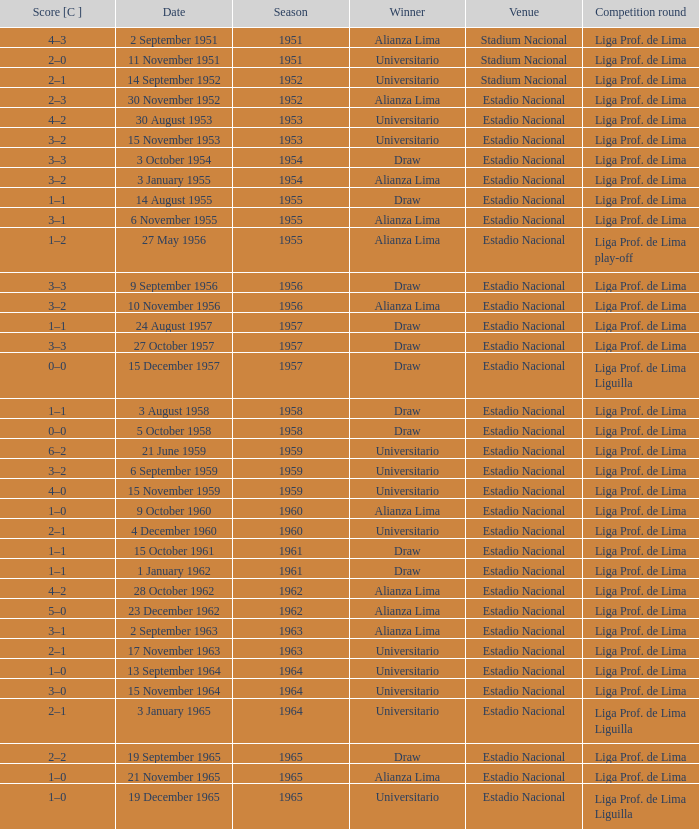What venue had an event on 17 November 1963? Estadio Nacional. Could you parse the entire table? {'header': ['Score [C ]', 'Date', 'Season', 'Winner', 'Venue', 'Competition round'], 'rows': [['4–3', '2 September 1951', '1951', 'Alianza Lima', 'Stadium Nacional', 'Liga Prof. de Lima'], ['2–0', '11 November 1951', '1951', 'Universitario', 'Stadium Nacional', 'Liga Prof. de Lima'], ['2–1', '14 September 1952', '1952', 'Universitario', 'Stadium Nacional', 'Liga Prof. de Lima'], ['2–3', '30 November 1952', '1952', 'Alianza Lima', 'Estadio Nacional', 'Liga Prof. de Lima'], ['4–2', '30 August 1953', '1953', 'Universitario', 'Estadio Nacional', 'Liga Prof. de Lima'], ['3–2', '15 November 1953', '1953', 'Universitario', 'Estadio Nacional', 'Liga Prof. de Lima'], ['3–3', '3 October 1954', '1954', 'Draw', 'Estadio Nacional', 'Liga Prof. de Lima'], ['3–2', '3 January 1955', '1954', 'Alianza Lima', 'Estadio Nacional', 'Liga Prof. de Lima'], ['1–1', '14 August 1955', '1955', 'Draw', 'Estadio Nacional', 'Liga Prof. de Lima'], ['3–1', '6 November 1955', '1955', 'Alianza Lima', 'Estadio Nacional', 'Liga Prof. de Lima'], ['1–2', '27 May 1956', '1955', 'Alianza Lima', 'Estadio Nacional', 'Liga Prof. de Lima play-off'], ['3–3', '9 September 1956', '1956', 'Draw', 'Estadio Nacional', 'Liga Prof. de Lima'], ['3–2', '10 November 1956', '1956', 'Alianza Lima', 'Estadio Nacional', 'Liga Prof. de Lima'], ['1–1', '24 August 1957', '1957', 'Draw', 'Estadio Nacional', 'Liga Prof. de Lima'], ['3–3', '27 October 1957', '1957', 'Draw', 'Estadio Nacional', 'Liga Prof. de Lima'], ['0–0', '15 December 1957', '1957', 'Draw', 'Estadio Nacional', 'Liga Prof. de Lima Liguilla'], ['1–1', '3 August 1958', '1958', 'Draw', 'Estadio Nacional', 'Liga Prof. de Lima'], ['0–0', '5 October 1958', '1958', 'Draw', 'Estadio Nacional', 'Liga Prof. de Lima'], ['6–2', '21 June 1959', '1959', 'Universitario', 'Estadio Nacional', 'Liga Prof. de Lima'], ['3–2', '6 September 1959', '1959', 'Universitario', 'Estadio Nacional', 'Liga Prof. de Lima'], ['4–0', '15 November 1959', '1959', 'Universitario', 'Estadio Nacional', 'Liga Prof. de Lima'], ['1–0', '9 October 1960', '1960', 'Alianza Lima', 'Estadio Nacional', 'Liga Prof. de Lima'], ['2–1', '4 December 1960', '1960', 'Universitario', 'Estadio Nacional', 'Liga Prof. de Lima'], ['1–1', '15 October 1961', '1961', 'Draw', 'Estadio Nacional', 'Liga Prof. de Lima'], ['1–1', '1 January 1962', '1961', 'Draw', 'Estadio Nacional', 'Liga Prof. de Lima'], ['4–2', '28 October 1962', '1962', 'Alianza Lima', 'Estadio Nacional', 'Liga Prof. de Lima'], ['5–0', '23 December 1962', '1962', 'Alianza Lima', 'Estadio Nacional', 'Liga Prof. de Lima'], ['3–1', '2 September 1963', '1963', 'Alianza Lima', 'Estadio Nacional', 'Liga Prof. de Lima'], ['2–1', '17 November 1963', '1963', 'Universitario', 'Estadio Nacional', 'Liga Prof. de Lima'], ['1–0', '13 September 1964', '1964', 'Universitario', 'Estadio Nacional', 'Liga Prof. de Lima'], ['3–0', '15 November 1964', '1964', 'Universitario', 'Estadio Nacional', 'Liga Prof. de Lima'], ['2–1', '3 January 1965', '1964', 'Universitario', 'Estadio Nacional', 'Liga Prof. de Lima Liguilla'], ['2–2', '19 September 1965', '1965', 'Draw', 'Estadio Nacional', 'Liga Prof. de Lima'], ['1–0', '21 November 1965', '1965', 'Alianza Lima', 'Estadio Nacional', 'Liga Prof. de Lima'], ['1–0', '19 December 1965', '1965', 'Universitario', 'Estadio Nacional', 'Liga Prof. de Lima Liguilla']]} 